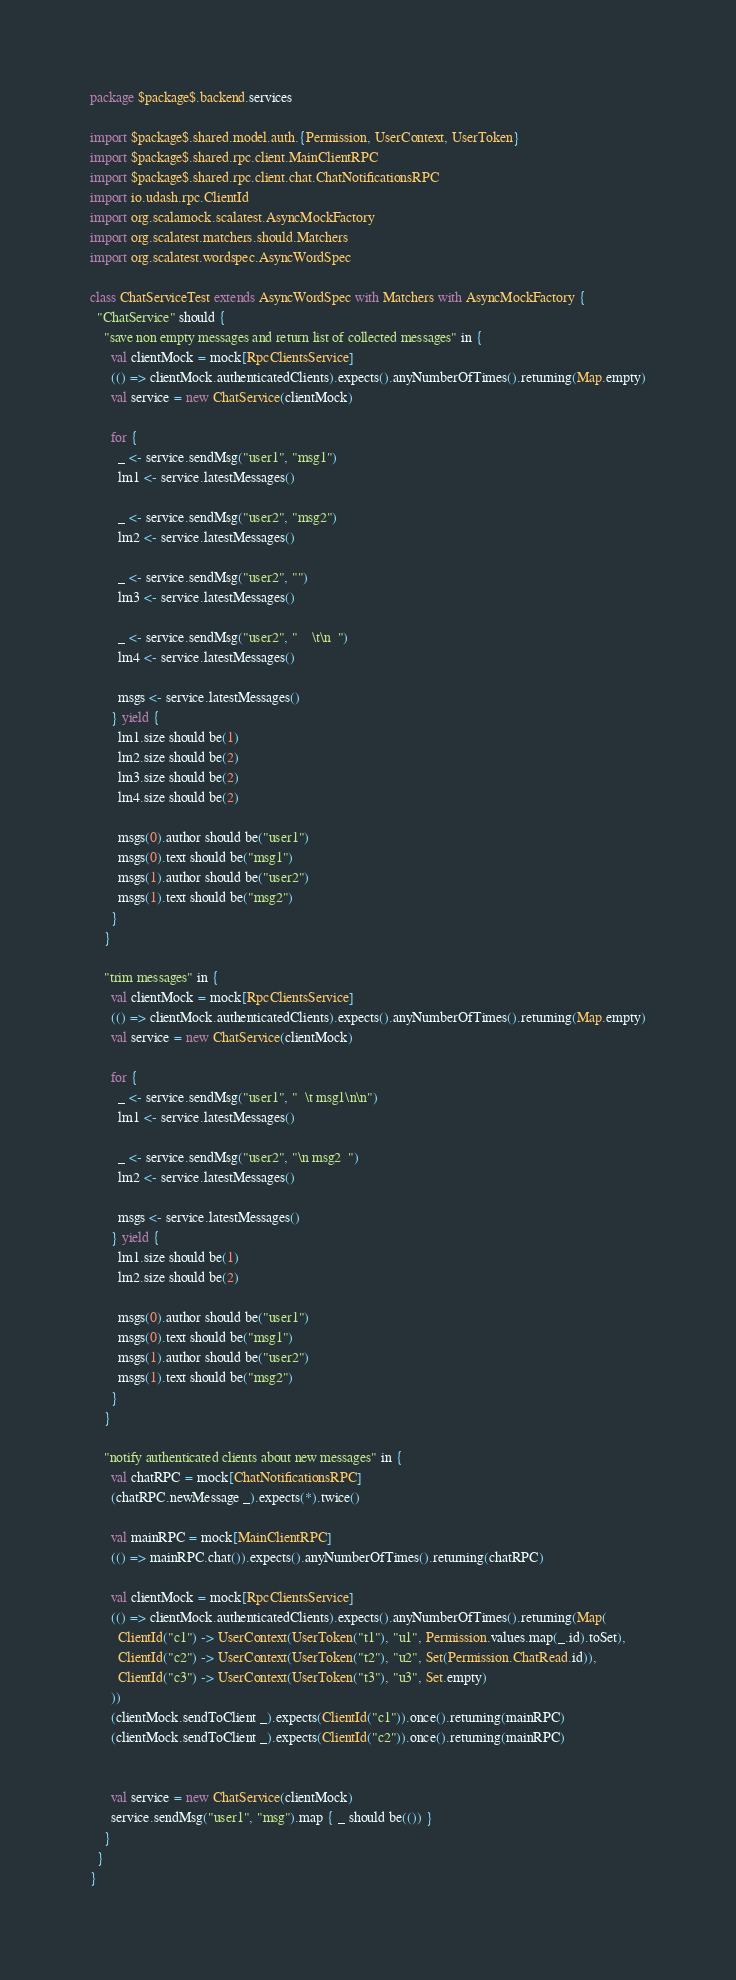<code> <loc_0><loc_0><loc_500><loc_500><_Scala_>package $package$.backend.services

import $package$.shared.model.auth.{Permission, UserContext, UserToken}
import $package$.shared.rpc.client.MainClientRPC
import $package$.shared.rpc.client.chat.ChatNotificationsRPC
import io.udash.rpc.ClientId
import org.scalamock.scalatest.AsyncMockFactory
import org.scalatest.matchers.should.Matchers
import org.scalatest.wordspec.AsyncWordSpec

class ChatServiceTest extends AsyncWordSpec with Matchers with AsyncMockFactory {
  "ChatService" should {
    "save non empty messages and return list of collected messages" in {
      val clientMock = mock[RpcClientsService]
      (() => clientMock.authenticatedClients).expects().anyNumberOfTimes().returning(Map.empty)
      val service = new ChatService(clientMock)

      for {
        _ <- service.sendMsg("user1", "msg1")
        lm1 <- service.latestMessages()

        _ <- service.sendMsg("user2", "msg2")
        lm2 <- service.latestMessages()

        _ <- service.sendMsg("user2", "")
        lm3 <- service.latestMessages()

        _ <- service.sendMsg("user2", "    \t\n  ")
        lm4 <- service.latestMessages()

        msgs <- service.latestMessages()
      } yield {
        lm1.size should be(1)
        lm2.size should be(2)
        lm3.size should be(2)
        lm4.size should be(2)

        msgs(0).author should be("user1")
        msgs(0).text should be("msg1")
        msgs(1).author should be("user2")
        msgs(1).text should be("msg2")
      }
    }

    "trim messages" in {
      val clientMock = mock[RpcClientsService]
      (() => clientMock.authenticatedClients).expects().anyNumberOfTimes().returning(Map.empty)
      val service = new ChatService(clientMock)

      for {
        _ <- service.sendMsg("user1", "  \t msg1\n\n")
        lm1 <- service.latestMessages()

        _ <- service.sendMsg("user2", "\n msg2  ")
        lm2 <- service.latestMessages()

        msgs <- service.latestMessages()
      } yield {
        lm1.size should be(1)
        lm2.size should be(2)

        msgs(0).author should be("user1")
        msgs(0).text should be("msg1")
        msgs(1).author should be("user2")
        msgs(1).text should be("msg2")
      }
    }

    "notify authenticated clients about new messages" in {
      val chatRPC = mock[ChatNotificationsRPC]
      (chatRPC.newMessage _).expects(*).twice()

      val mainRPC = mock[MainClientRPC]
      (() => mainRPC.chat()).expects().anyNumberOfTimes().returning(chatRPC)

      val clientMock = mock[RpcClientsService]
      (() => clientMock.authenticatedClients).expects().anyNumberOfTimes().returning(Map(
        ClientId("c1") -> UserContext(UserToken("t1"), "u1", Permission.values.map(_.id).toSet),
        ClientId("c2") -> UserContext(UserToken("t2"), "u2", Set(Permission.ChatRead.id)),
        ClientId("c3") -> UserContext(UserToken("t3"), "u3", Set.empty)
      ))
      (clientMock.sendToClient _).expects(ClientId("c1")).once().returning(mainRPC)
      (clientMock.sendToClient _).expects(ClientId("c2")).once().returning(mainRPC)


      val service = new ChatService(clientMock)
      service.sendMsg("user1", "msg").map { _ should be(()) }
    }
  }
}
</code> 